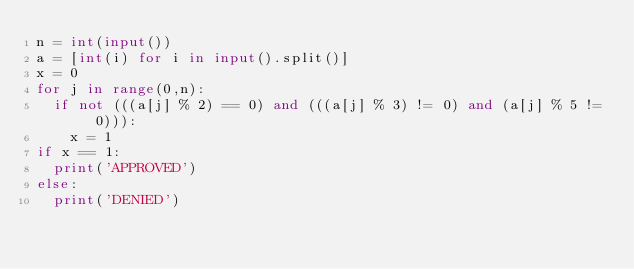<code> <loc_0><loc_0><loc_500><loc_500><_Python_>n = int(input())
a = [int(i) for i in input().split()]
x = 0
for j in range(0,n):
  if not (((a[j] % 2) == 0) and (((a[j] % 3) != 0) and (a[j] % 5 != 0))):
    x = 1
if x == 1:
  print('APPROVED')
else:
  print('DENIED')</code> 